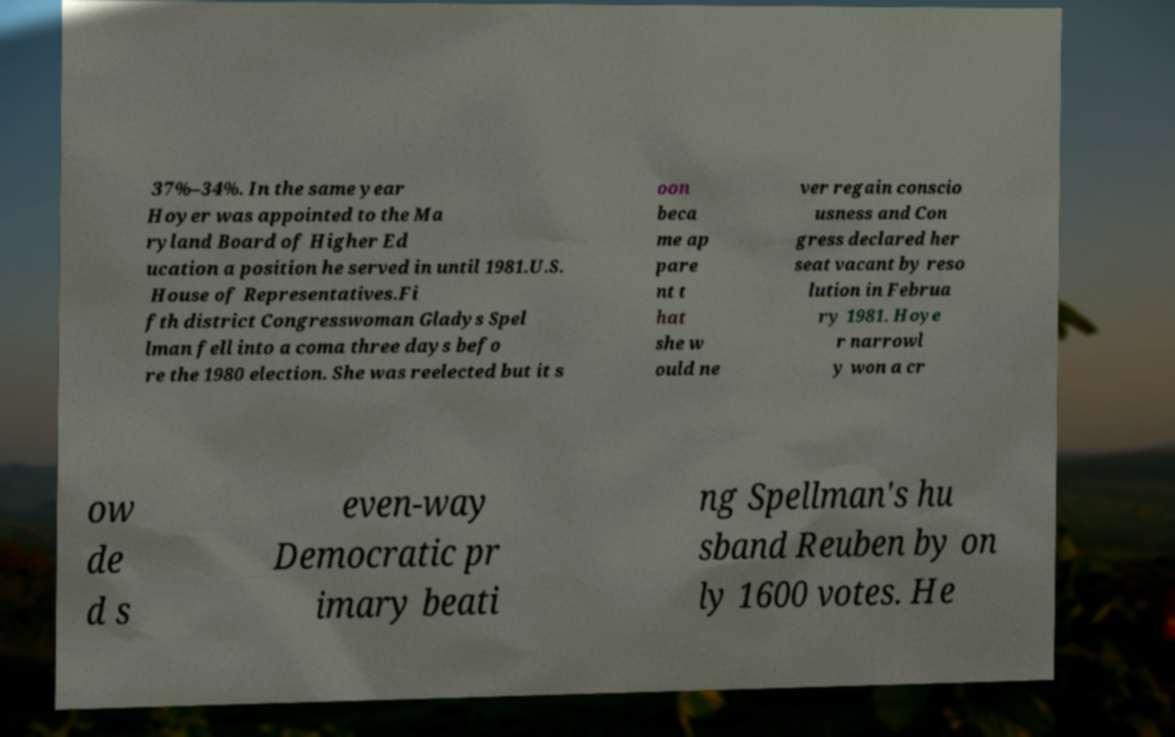Could you extract and type out the text from this image? 37%–34%. In the same year Hoyer was appointed to the Ma ryland Board of Higher Ed ucation a position he served in until 1981.U.S. House of Representatives.Fi fth district Congresswoman Gladys Spel lman fell into a coma three days befo re the 1980 election. She was reelected but it s oon beca me ap pare nt t hat she w ould ne ver regain conscio usness and Con gress declared her seat vacant by reso lution in Februa ry 1981. Hoye r narrowl y won a cr ow de d s even-way Democratic pr imary beati ng Spellman's hu sband Reuben by on ly 1600 votes. He 